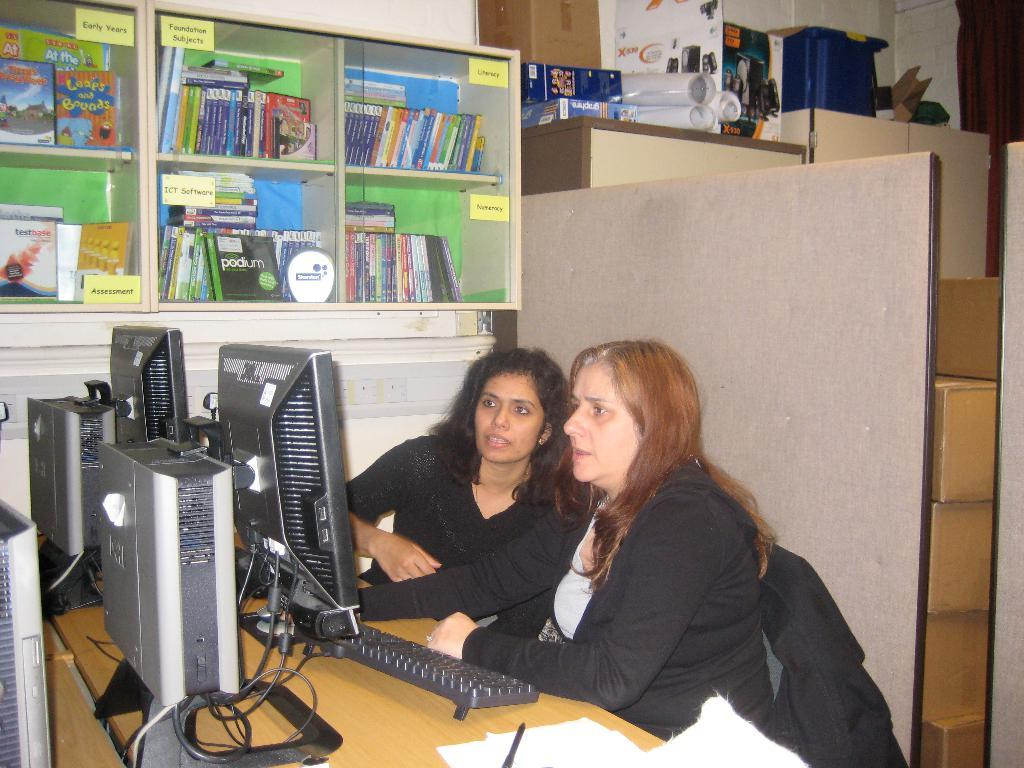How many women are present in the image? There are 2 women in the image. What are the women doing in the image? The women are sitting in chairs and watching a computer. What can be seen in the background of the image? There are books in a rack, papers, and boxes in a cupboard in the background. What type of border is visible in the image? There is no border visible in the image. How are the women transporting themselves in the image? The women are not transporting themselves in the image; they are sitting in chairs. 